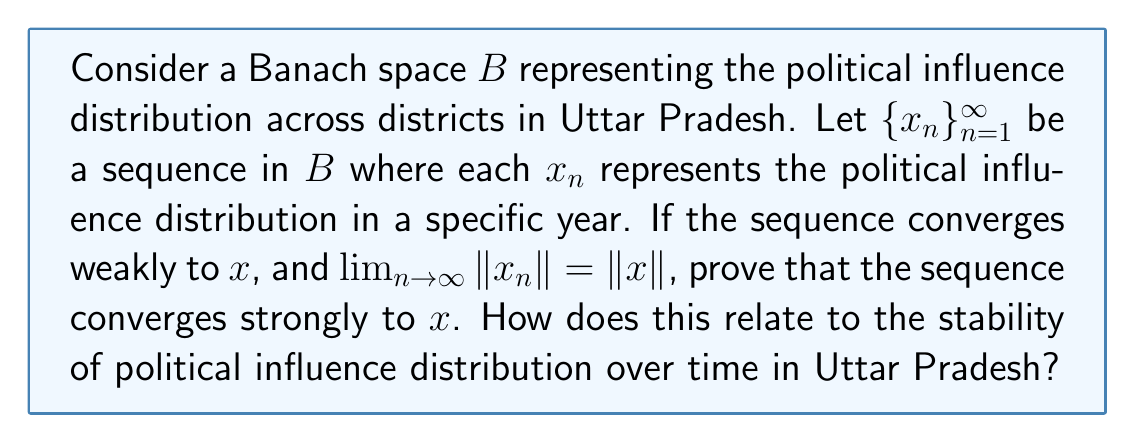Can you solve this math problem? To prove that the sequence converges strongly to $x$, we will use the following steps:

1) We are given that $\{x_n\}$ converges weakly to $x$, which means:
   $$f(x_n) \to f(x)$$ for all $f \in B^*$ (the dual space of $B$)

2) We are also given that $\lim_{n\to\infty} \|x_n\| = \|x\|$

3) In a Banach space, we can use the following identity:
   $$\|x_n - x\|^2 = \|x_n\|^2 + \|x\|^2 - 2\text{Re}\langle x_n, x \rangle$$

4) As $n \to \infty$, the right-hand side becomes:
   $$\lim_{n\to\infty} \|x_n\|^2 + \|x\|^2 - 2\text{Re}\langle x_n, x \rangle$$
   $$= \|x\|^2 + \|x\|^2 - 2\text{Re}\langle x, x \rangle$$
   $$= 2\|x\|^2 - 2\|x\|^2 = 0$$

5) Therefore, $\lim_{n\to\infty} \|x_n - x\|^2 = 0$, which implies $\lim_{n\to\infty} \|x_n - x\| = 0$

This proves that the sequence converges strongly to $x$.

In the context of political influence distribution in Uttar Pradesh, this result suggests that if the distribution of political influence across districts (represented by $x_n$) converges weakly to a particular distribution ($x$) over time, and the total amount of influence (represented by the norm) stabilizes, then the distribution is actually converging strongly. This implies a stable and predictable political landscape in the long term, where the influence distribution across districts becomes increasingly similar to a fixed pattern.
Answer: The sequence $\{x_n\}$ converges strongly to $x$ in the Banach space $B$. This indicates that the political influence distribution in Uttar Pradesh is likely to stabilize over time, approaching a fixed pattern of distribution across districts. 